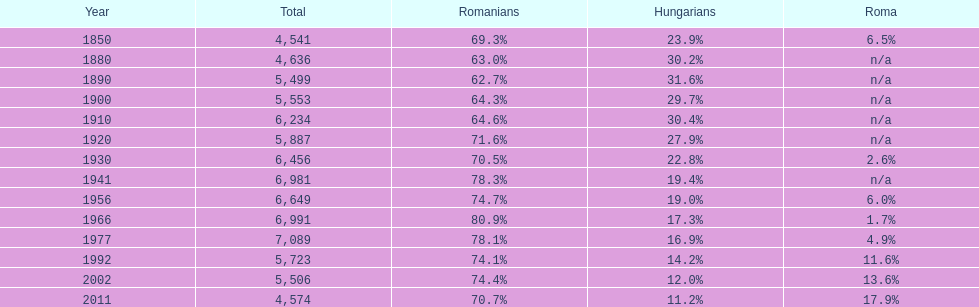What were the total number of times the romanians had a population percentage above 70%? 9. 